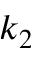Convert formula to latex. <formula><loc_0><loc_0><loc_500><loc_500>k _ { 2 }</formula> 